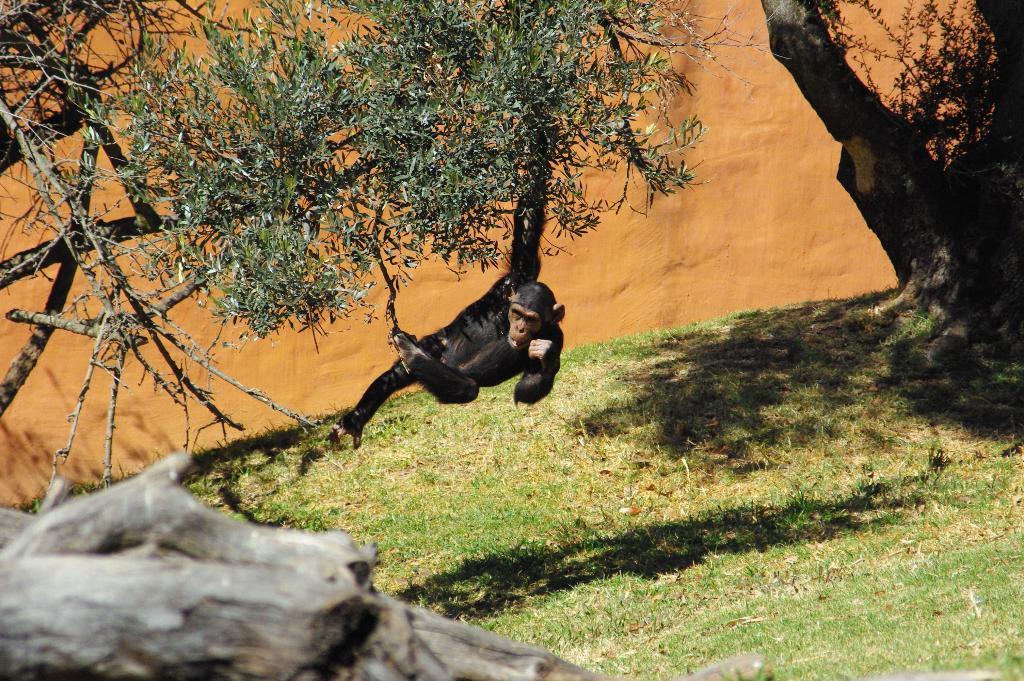Please provide a concise description of this image. In the center of the image we can see a chimpanzee. In the background of the image we can see the trees and wall. At the bottom of the image we can see the ground. In the bottom left corner we can see a rock. 